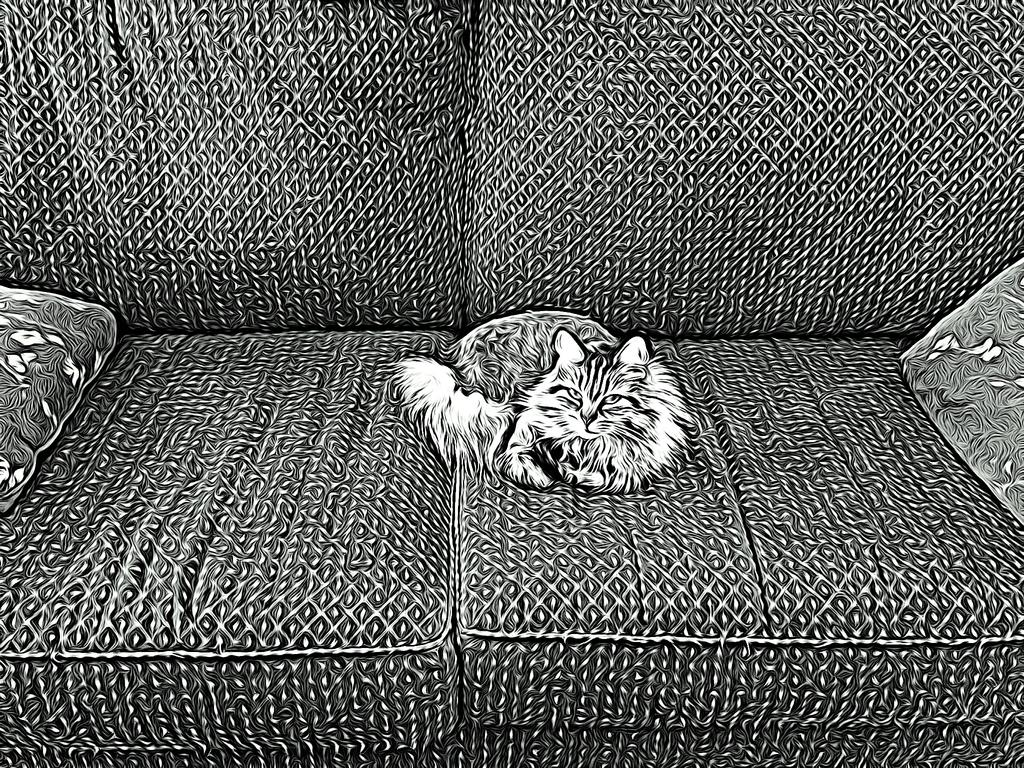What type of animal is in the image? There is a cat in the image. Where is the cat sitting? The cat is sitting on a cushion. What type of steel is used to make the brake in the image? There is no steel or brake present in the image; it features a cat sitting on a cushion. 